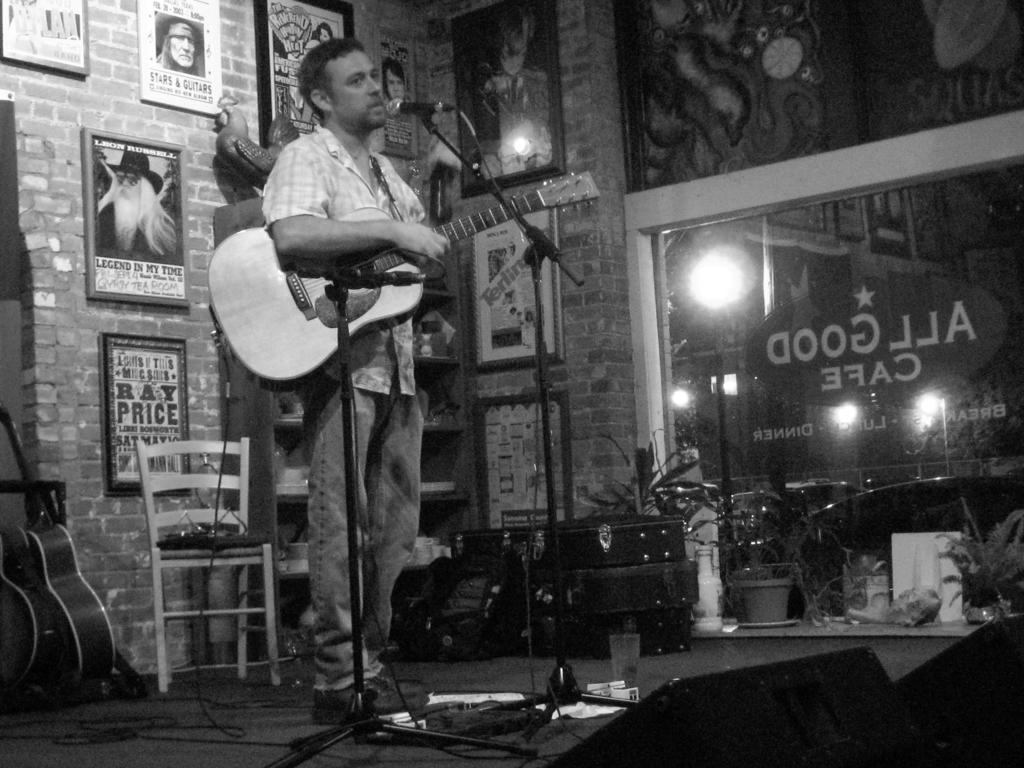Please provide a concise description of this image. The picture is in black and white. A person is standing on the stage and playing a guitar. In front of him there are two mikes. Behind him there is a wall full of frames. To the left bottom there are some more guitars. To the right corner there are some plants and a window. 